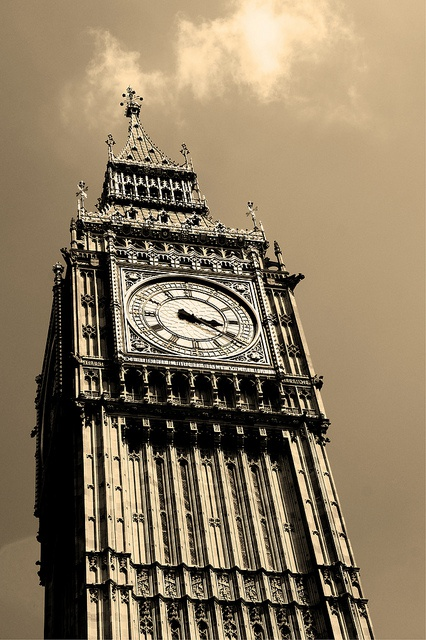Describe the objects in this image and their specific colors. I can see a clock in gray, ivory, black, tan, and darkgray tones in this image. 